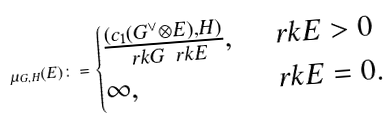Convert formula to latex. <formula><loc_0><loc_0><loc_500><loc_500>\mu _ { G , H } ( E ) \colon = \begin{cases} \frac { ( c _ { 1 } ( G ^ { \vee } \otimes E ) , H ) } { \ r k G \ r k E } , \, & \ r k E > 0 \\ \infty , \, & \ r k E = 0 . \end{cases}</formula> 